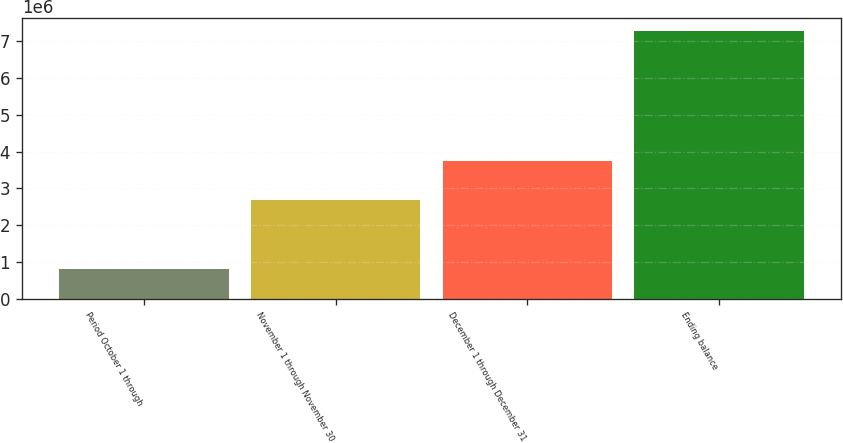<chart> <loc_0><loc_0><loc_500><loc_500><bar_chart><fcel>Period October 1 through<fcel>November 1 through November 30<fcel>December 1 through December 31<fcel>Ending balance<nl><fcel>824990<fcel>2.69703e+06<fcel>3.7458e+06<fcel>7.26782e+06<nl></chart> 